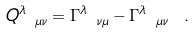<formula> <loc_0><loc_0><loc_500><loc_500>Q ^ { \lambda } _ { \ \mu \nu } = \Gamma ^ { \lambda } _ { \ \nu \mu } - \Gamma ^ { \lambda } _ { \ \mu \nu } \ .</formula> 